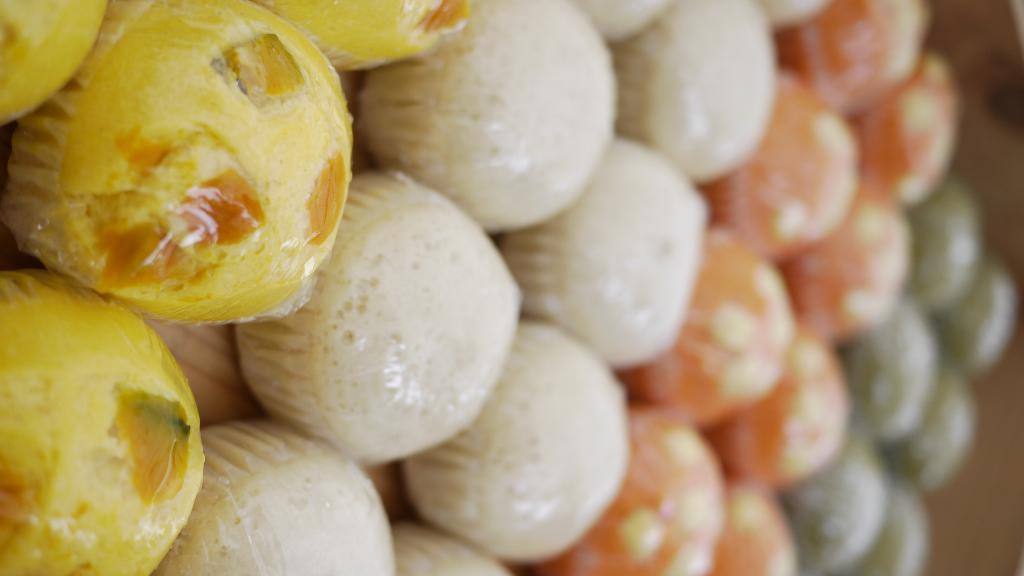In one or two sentences, can you explain what this image depicts? In this image we can see the close view of the food item which are in yellow color, white color, orange color, and in green color. This part of the image is slightly blurred. 